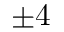<formula> <loc_0><loc_0><loc_500><loc_500>\pm 4</formula> 